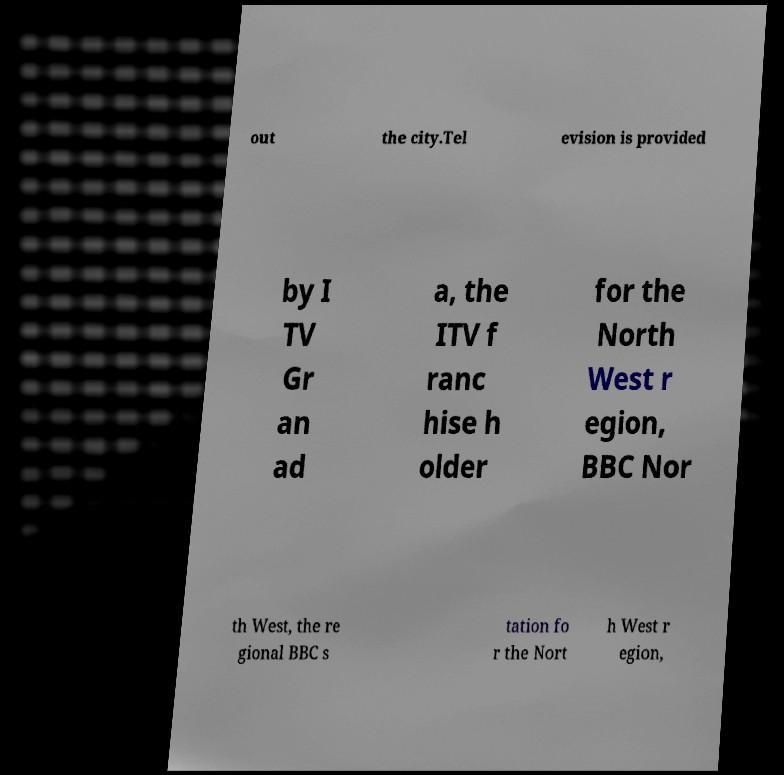For documentation purposes, I need the text within this image transcribed. Could you provide that? out the city.Tel evision is provided by I TV Gr an ad a, the ITV f ranc hise h older for the North West r egion, BBC Nor th West, the re gional BBC s tation fo r the Nort h West r egion, 